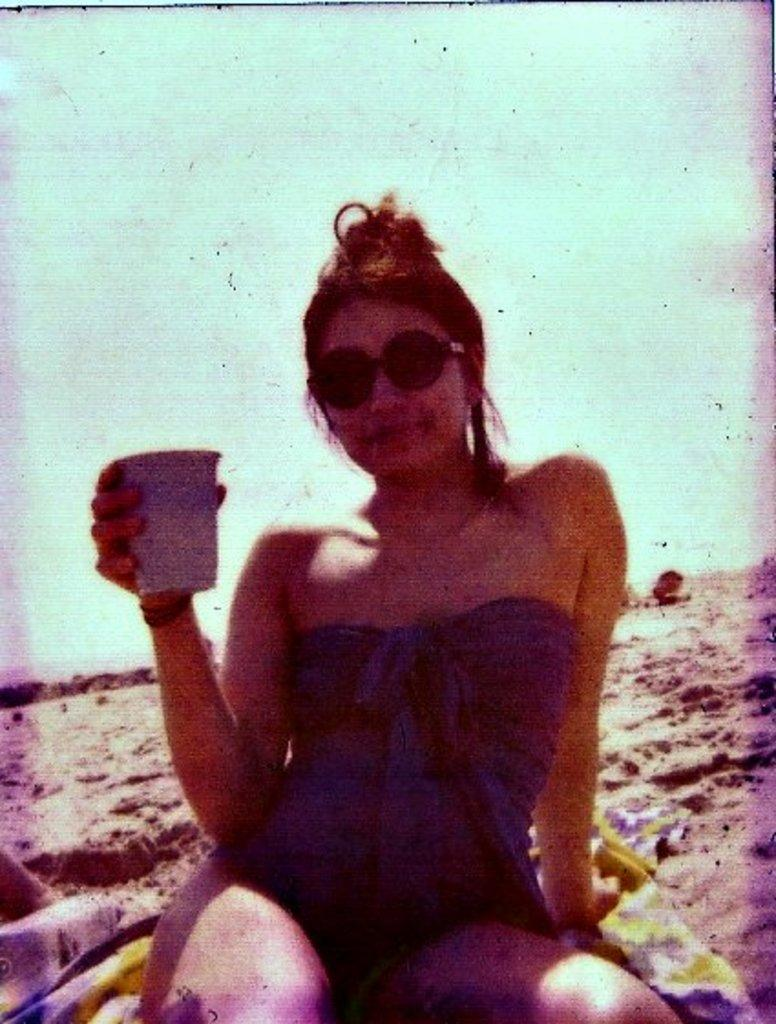What is the main subject of the image? The main subject of the image is an old photograph. Who is featured in the photograph? The photograph features a woman. What is the woman wearing in the photograph? The woman is wearing a black top. Where is the woman sitting in the photograph? The woman is sitting on the beach side. What is the woman holding in the photograph? The woman is holding a tea cup in her hand. What expression does the woman have in the photograph? The woman is smiling. What can be seen in the background of the photograph? Beach sand is visible in the background of the photograph. What type of scissors can be seen in the woman's hand in the photograph? There are no scissors visible in the woman's hand in the photograph; she is holding a tea cup. Can you see any fangs on the woman in the photograph? There are no fangs visible on the woman in the photograph; she is smiling and appears to have normal teeth. 